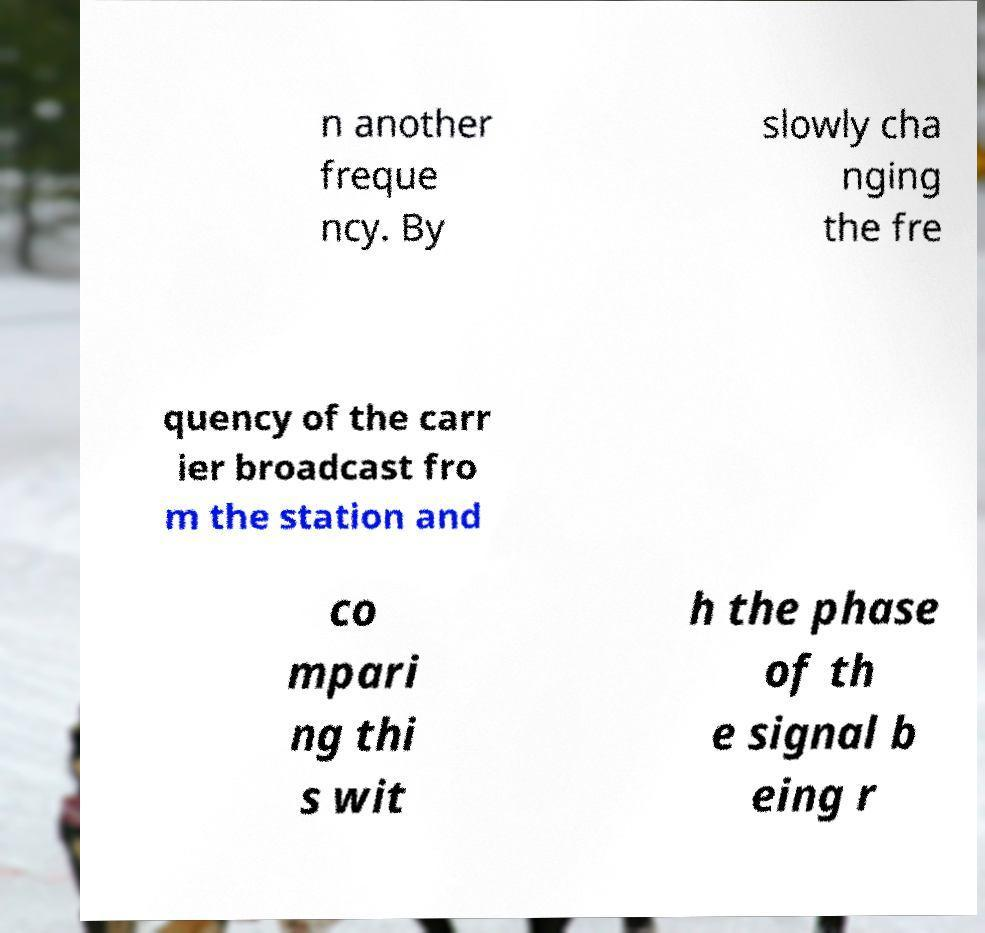Could you assist in decoding the text presented in this image and type it out clearly? n another freque ncy. By slowly cha nging the fre quency of the carr ier broadcast fro m the station and co mpari ng thi s wit h the phase of th e signal b eing r 